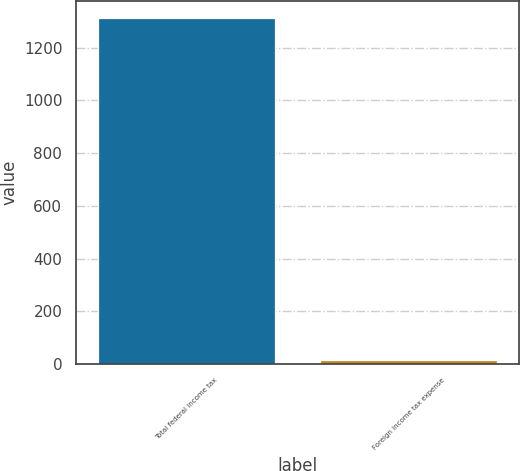Convert chart to OTSL. <chart><loc_0><loc_0><loc_500><loc_500><bar_chart><fcel>Total federal income tax<fcel>Foreign income tax expense<nl><fcel>1312<fcel>14<nl></chart> 